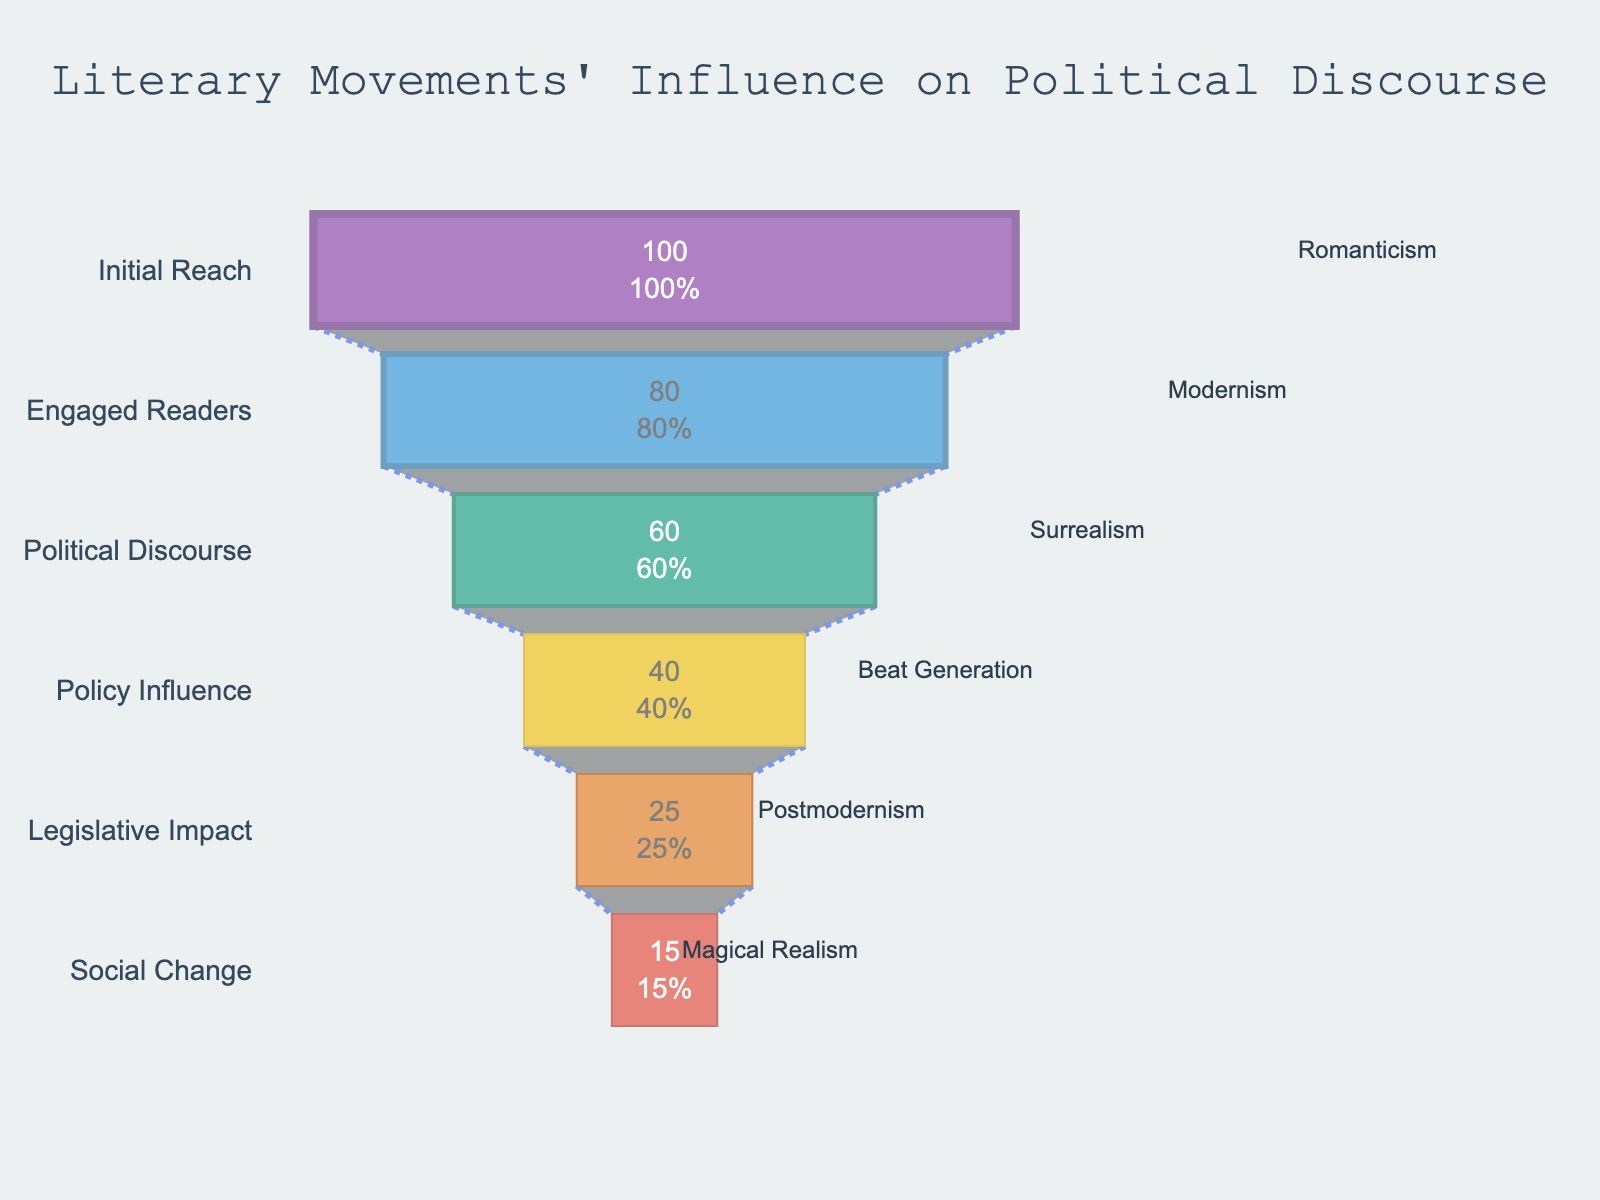what is the title of the funnel chart? The title of the funnel chart can be found at the top, centered, and is usually in a larger font size compared to other text.
Answer: Literary Movements' Influence on Political Discourse How many stages are represented in the funnel chart? To find the number of stages, count the individual sections or layers of the funnel. Each stage corresponds to a different literary movement and is labeled on the y-axis.
Answer: 6 What is the influence value for the Romanticism movement? Locate the bar corresponding to the Romanticism movement. The influence value is indicated directly inside the bar.
Answer: 100 Which literary movement has the smallest influence on political discourse? Look for the stage with the smallest value represented in the chart. The movement corresponding to this stage will have the smallest influence.
Answer: Magical Realism What is the difference in influence between Modernism and the Beat Generation? Find the influence values for both Modernism and the Beat Generation. Subtract the Beat Generation's influence from Modernism's influence.
Answer: 80 - 40 = 40 Which stage shows a transition from the Beat Generation? Identify the stage that follows the Beat Generation in terms of influence. Look directly at the next layer in the funnel chart.
Answer: Postmodernism How much more influence does Romanticism have compared to Postmodernism? Find the influence values for both Romanticism and Postmodernism. Subtract the Postmodernism's influence from Romanticism's influence.
Answer: 100 - 25 = 75 Which movement has nearly half the influence of Romanticism? To determine half the influence of Romanticism, divide its influence value by 2. Find the movement that has an influence value close to this number.
Answer: Surrealism (half of 100 is 50, and Surrealism has 60) What percentage of the initial reach does Modernism maintain? Look at the value and percent initial text inside the bar for Modernism. This shows how much of the initial reach (Romanticism) Modernism maintains in percentage terms.
Answer: 80% How does the influence of Surrealism compare to the Beat Generation? Compare the influence values of Surrealism and the Beat Generation. Check whether the influence of Surrealism is greater than, less than, or equal to the Beat Generation.
Answer: Greater than 